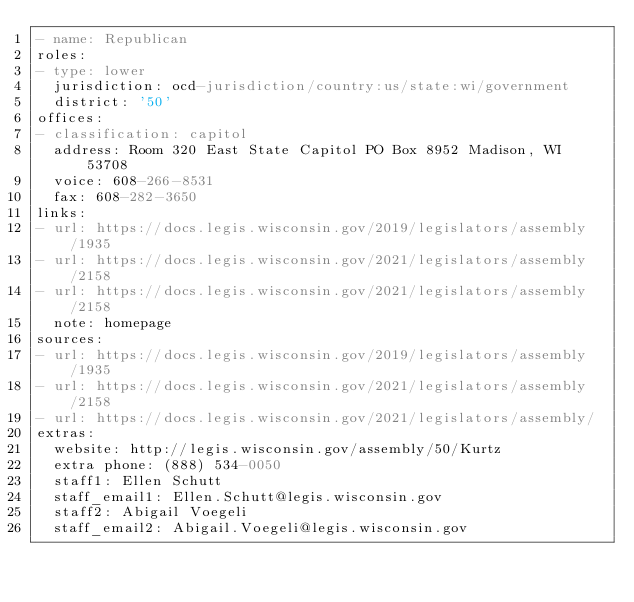<code> <loc_0><loc_0><loc_500><loc_500><_YAML_>- name: Republican
roles:
- type: lower
  jurisdiction: ocd-jurisdiction/country:us/state:wi/government
  district: '50'
offices:
- classification: capitol
  address: Room 320 East State Capitol PO Box 8952 Madison, WI 53708
  voice: 608-266-8531
  fax: 608-282-3650
links:
- url: https://docs.legis.wisconsin.gov/2019/legislators/assembly/1935
- url: https://docs.legis.wisconsin.gov/2021/legislators/assembly/2158
- url: https://docs.legis.wisconsin.gov/2021/legislators/assembly/2158
  note: homepage
sources:
- url: https://docs.legis.wisconsin.gov/2019/legislators/assembly/1935
- url: https://docs.legis.wisconsin.gov/2021/legislators/assembly/2158
- url: https://docs.legis.wisconsin.gov/2021/legislators/assembly/
extras:
  website: http://legis.wisconsin.gov/assembly/50/Kurtz
  extra phone: (888) 534-0050
  staff1: Ellen Schutt
  staff_email1: Ellen.Schutt@legis.wisconsin.gov
  staff2: Abigail Voegeli
  staff_email2: Abigail.Voegeli@legis.wisconsin.gov
</code> 